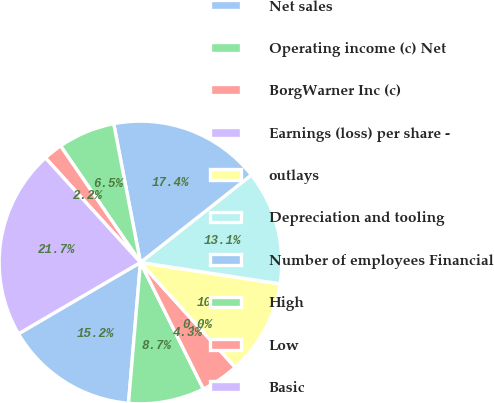Convert chart. <chart><loc_0><loc_0><loc_500><loc_500><pie_chart><fcel>Net sales<fcel>Operating income (c) Net<fcel>BorgWarner Inc (c)<fcel>Earnings (loss) per share -<fcel>outlays<fcel>Depreciation and tooling<fcel>Number of employees Financial<fcel>High<fcel>Low<fcel>Basic<nl><fcel>15.23%<fcel>8.7%<fcel>4.35%<fcel>0.0%<fcel>10.88%<fcel>13.05%<fcel>17.4%<fcel>6.53%<fcel>2.18%<fcel>21.68%<nl></chart> 